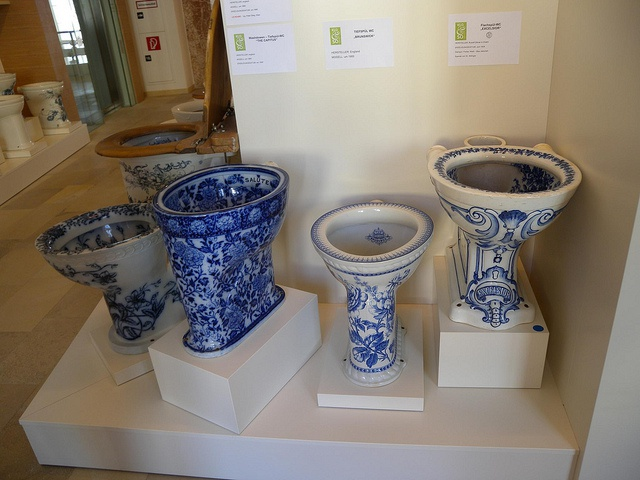Describe the objects in this image and their specific colors. I can see vase in maroon, navy, black, and gray tones, toilet in maroon, navy, black, and gray tones, toilet in maroon, darkgray, gray, and black tones, toilet in maroon, darkgray, gray, and navy tones, and vase in maroon, darkgray, gray, and navy tones in this image. 